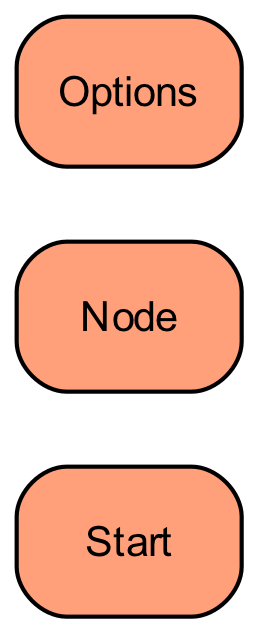What is the starting point of the education pathways in the diagram? The starting point of the education pathways is the "Child's Age" node, from which different age categories are explored.
Answer: Child's Age How many options are available under the "Age 3-5" category? Under the "Age 3-5" category, there are two main options: "Nursery" and "Local Nursery." Hence, there are a total of 2 options.
Answer: 2 What is the next step after a child completes the "Primary School" node with an IGCSE curriculum? After completing the "Primary School" with an IGCSE curriculum, the next step is "Middle School."
Answer: Middle School Which curriculum options are available under the "International Schools" for the "High School" node? There are two curriculum options available under "International Schools" for the "High School" node: "CBSE Board" and "IGCSE/A Level."
Answer: CBSE Board, IGCSE/A Level What is the relationship between "Local Schools" in the "Middle School" node and "High School"? "Local Schools" in the "Middle School" node follow the same Saudi National Curriculum from Middle School to High School, leading to consistency in the educational pathway.
Answer: Saudi National Curriculum How many different school types are there for the "Age 11-14" category? There are two types of schools available for the "Age 11-14" category: "International Schools" and "Local Schools." Therefore, the total school types are 2.
Answer: 2 If a child starts from the "Local Nursery," what curriculum will they follow leading to Primary School? A child starting from the "Local Nursery" will follow the "Saudi National Curriculum," which directly leads to Primary School.
Answer: Saudi National Curriculum What are the options for "International Schools" after completing Middle School for Age 11-14? The options for "International Schools" after completing Middle School are the "CBSE Curriculum" and "IGCSE," both of which lead to High School.
Answer: CBSE Curriculum, IGCSE 